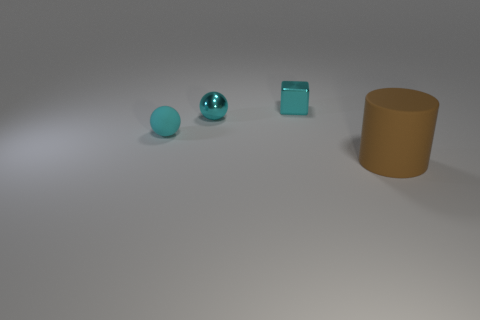There is a thing that is in front of the tiny metallic ball and on the left side of the large matte object; what material is it made of?
Provide a short and direct response. Rubber. What is the color of the rubber thing that is the same size as the cyan metal block?
Your response must be concise. Cyan. Does the cylinder have the same material as the small ball that is on the right side of the matte ball?
Make the answer very short. No. What number of other things are there of the same size as the cyan metallic ball?
Provide a succinct answer. 2. Is there a cyan cube that is behind the small ball that is on the left side of the small cyan metal thing that is left of the small cyan cube?
Provide a succinct answer. Yes. What is the size of the cyan block?
Keep it short and to the point. Small. There is a matte thing behind the matte cylinder; what size is it?
Keep it short and to the point. Small. There is a rubber object behind the brown object; does it have the same size as the cyan metal ball?
Ensure brevity in your answer.  Yes. Is there any other thing that has the same color as the small cube?
Your response must be concise. Yes. What is the shape of the brown rubber thing?
Offer a very short reply. Cylinder. 